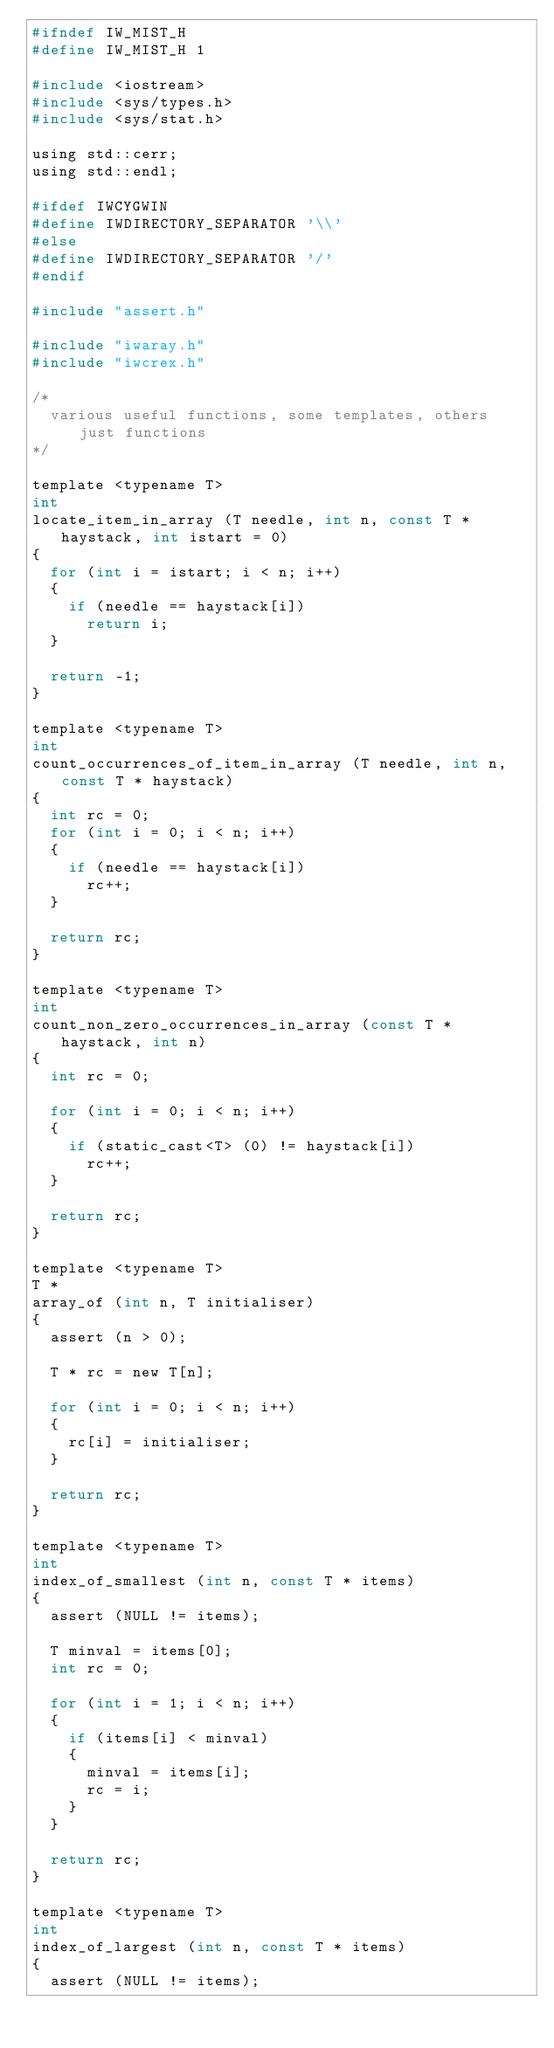<code> <loc_0><loc_0><loc_500><loc_500><_C_>#ifndef IW_MIST_H
#define IW_MIST_H 1

#include <iostream>
#include <sys/types.h>
#include <sys/stat.h>

using std::cerr;
using std::endl;

#ifdef IWCYGWIN
#define IWDIRECTORY_SEPARATOR '\\'
#else
#define IWDIRECTORY_SEPARATOR '/'
#endif

#include "assert.h"

#include "iwaray.h"
#include "iwcrex.h"

/*
  various useful functions, some templates, others just functions
*/

template <typename T>
int
locate_item_in_array (T needle, int n, const T * haystack, int istart = 0)
{
  for (int i = istart; i < n; i++)
  {
    if (needle == haystack[i])
      return i;
  }

  return -1;
}

template <typename T>
int
count_occurrences_of_item_in_array (T needle, int n, const T * haystack)
{
  int rc = 0;
  for (int i = 0; i < n; i++)
  {
    if (needle == haystack[i])
      rc++;
  }

  return rc;
}

template <typename T>
int
count_non_zero_occurrences_in_array (const T * haystack, int n)
{
  int rc = 0;

  for (int i = 0; i < n; i++)
  {
    if (static_cast<T> (0) != haystack[i])
      rc++;
  }

  return rc;
}

template <typename T>
T *
array_of (int n, T initialiser)
{
  assert (n > 0);

  T * rc = new T[n];

  for (int i = 0; i < n; i++)
  {
    rc[i] = initialiser;
  }

  return rc;
}

template <typename T>
int
index_of_smallest (int n, const T * items)
{
  assert (NULL != items);

  T minval = items[0];
  int rc = 0;

  for (int i = 1; i < n; i++)
  {
    if (items[i] < minval)
    {
      minval = items[i];
      rc = i;
    }
  }

  return rc;
}

template <typename T>
int
index_of_largest (int n, const T * items)
{
  assert (NULL != items);
</code> 